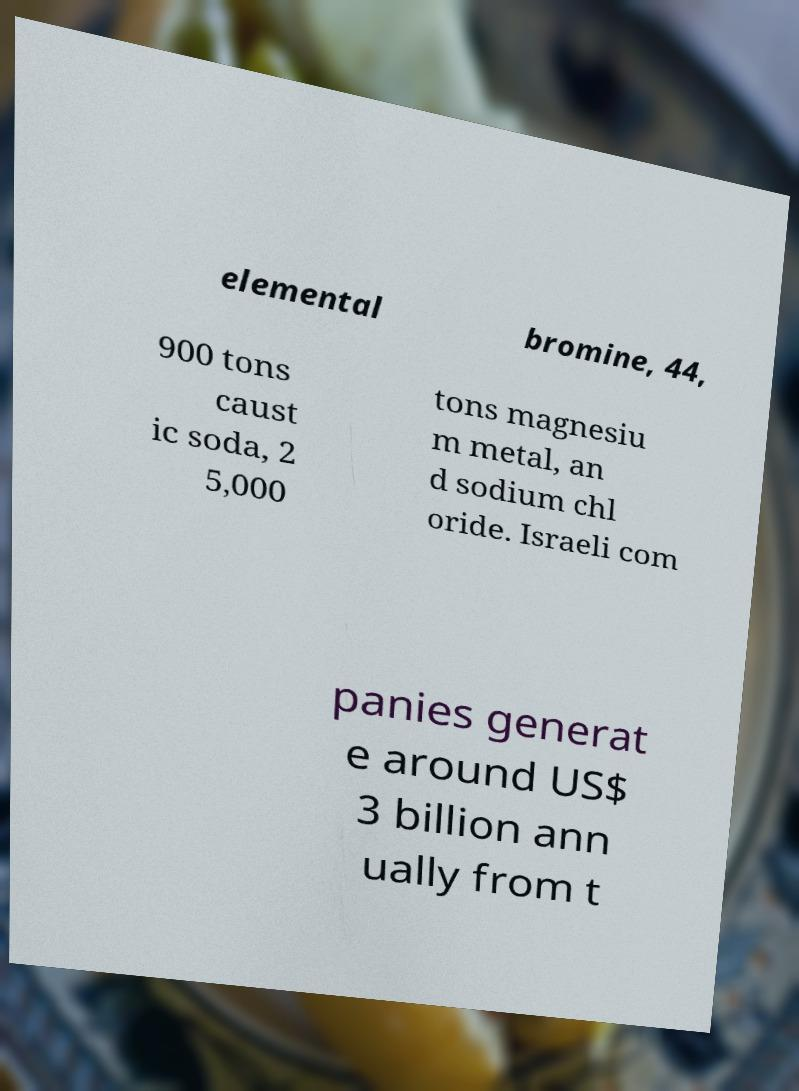For documentation purposes, I need the text within this image transcribed. Could you provide that? elemental bromine, 44, 900 tons caust ic soda, 2 5,000 tons magnesiu m metal, an d sodium chl oride. Israeli com panies generat e around US$ 3 billion ann ually from t 